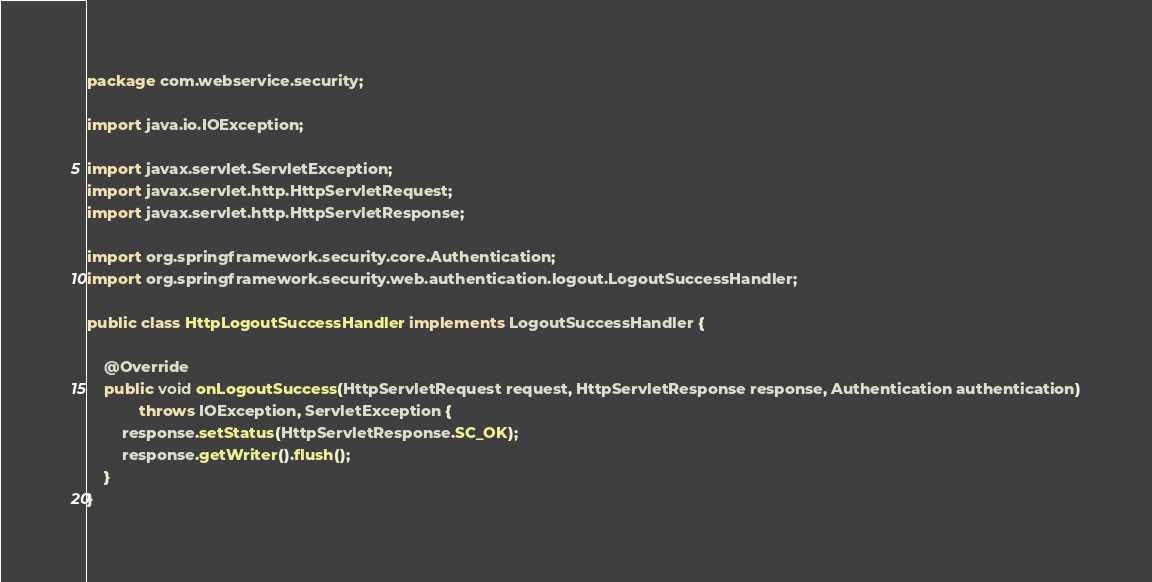<code> <loc_0><loc_0><loc_500><loc_500><_Java_>package com.webservice.security;

import java.io.IOException;

import javax.servlet.ServletException;
import javax.servlet.http.HttpServletRequest;
import javax.servlet.http.HttpServletResponse;

import org.springframework.security.core.Authentication;
import org.springframework.security.web.authentication.logout.LogoutSuccessHandler;

public class HttpLogoutSuccessHandler implements LogoutSuccessHandler {

	@Override
	public void onLogoutSuccess(HttpServletRequest request, HttpServletResponse response, Authentication authentication)
			throws IOException, ServletException {
		response.setStatus(HttpServletResponse.SC_OK);
		response.getWriter().flush();
	}
}
</code> 